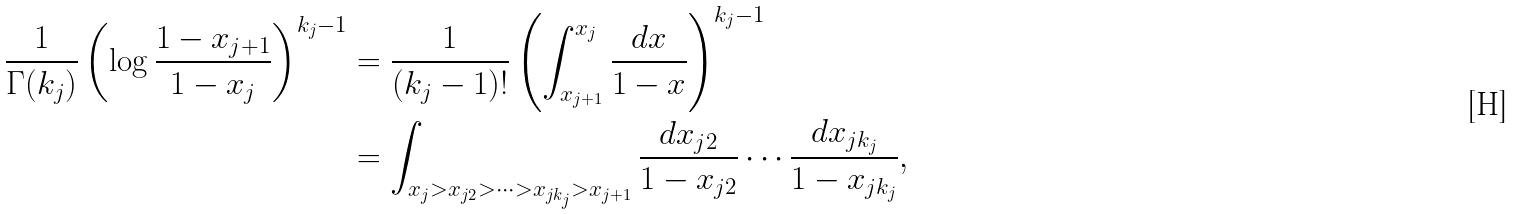Convert formula to latex. <formula><loc_0><loc_0><loc_500><loc_500>\frac { 1 } { \Gamma ( k _ { j } ) } \left ( \log \frac { 1 - x _ { j + 1 } } { 1 - x _ { j } } \right ) ^ { k _ { j } - 1 } & = \frac { 1 } { ( k _ { j } - 1 ) ! } \left ( \int _ { x _ { j + 1 } } ^ { x _ { j } } \frac { d x } { 1 - x } \right ) ^ { k _ { j } - 1 } \\ & = \int _ { x _ { j } > x _ { j 2 } > \cdots > x _ { j k _ { j } } > x _ { j + 1 } } \frac { d x _ { j 2 } } { 1 - x _ { j 2 } } \cdots \frac { d x _ { j k _ { j } } } { 1 - x _ { j k _ { j } } } ,</formula> 